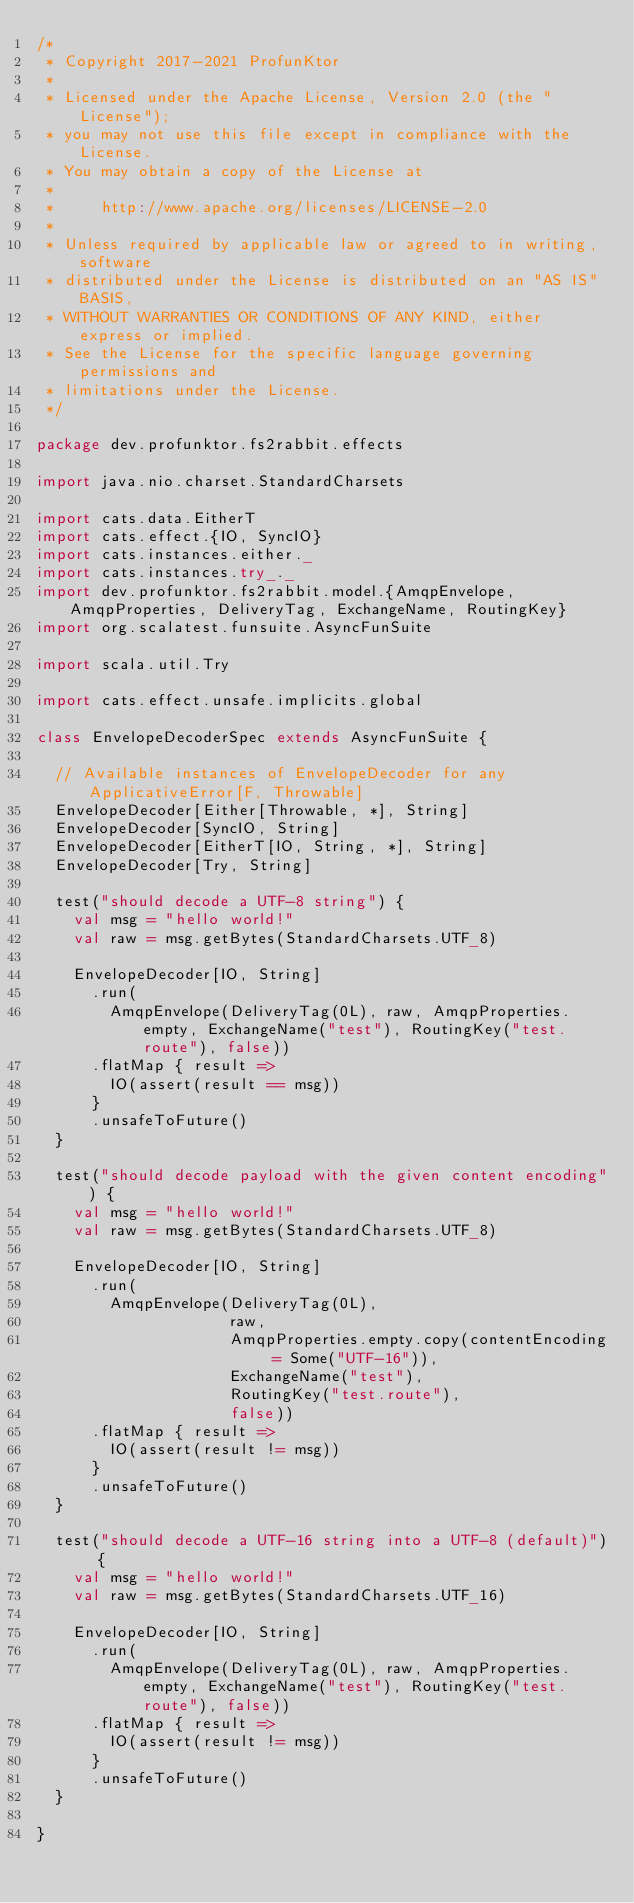<code> <loc_0><loc_0><loc_500><loc_500><_Scala_>/*
 * Copyright 2017-2021 ProfunKtor
 *
 * Licensed under the Apache License, Version 2.0 (the "License");
 * you may not use this file except in compliance with the License.
 * You may obtain a copy of the License at
 *
 *     http://www.apache.org/licenses/LICENSE-2.0
 *
 * Unless required by applicable law or agreed to in writing, software
 * distributed under the License is distributed on an "AS IS" BASIS,
 * WITHOUT WARRANTIES OR CONDITIONS OF ANY KIND, either express or implied.
 * See the License for the specific language governing permissions and
 * limitations under the License.
 */

package dev.profunktor.fs2rabbit.effects

import java.nio.charset.StandardCharsets

import cats.data.EitherT
import cats.effect.{IO, SyncIO}
import cats.instances.either._
import cats.instances.try_._
import dev.profunktor.fs2rabbit.model.{AmqpEnvelope, AmqpProperties, DeliveryTag, ExchangeName, RoutingKey}
import org.scalatest.funsuite.AsyncFunSuite

import scala.util.Try

import cats.effect.unsafe.implicits.global

class EnvelopeDecoderSpec extends AsyncFunSuite {

  // Available instances of EnvelopeDecoder for any ApplicativeError[F, Throwable]
  EnvelopeDecoder[Either[Throwable, *], String]
  EnvelopeDecoder[SyncIO, String]
  EnvelopeDecoder[EitherT[IO, String, *], String]
  EnvelopeDecoder[Try, String]

  test("should decode a UTF-8 string") {
    val msg = "hello world!"
    val raw = msg.getBytes(StandardCharsets.UTF_8)

    EnvelopeDecoder[IO, String]
      .run(
        AmqpEnvelope(DeliveryTag(0L), raw, AmqpProperties.empty, ExchangeName("test"), RoutingKey("test.route"), false))
      .flatMap { result =>
        IO(assert(result == msg))
      }
      .unsafeToFuture()
  }

  test("should decode payload with the given content encoding") {
    val msg = "hello world!"
    val raw = msg.getBytes(StandardCharsets.UTF_8)

    EnvelopeDecoder[IO, String]
      .run(
        AmqpEnvelope(DeliveryTag(0L),
                     raw,
                     AmqpProperties.empty.copy(contentEncoding = Some("UTF-16")),
                     ExchangeName("test"),
                     RoutingKey("test.route"),
                     false))
      .flatMap { result =>
        IO(assert(result != msg))
      }
      .unsafeToFuture()
  }

  test("should decode a UTF-16 string into a UTF-8 (default)") {
    val msg = "hello world!"
    val raw = msg.getBytes(StandardCharsets.UTF_16)

    EnvelopeDecoder[IO, String]
      .run(
        AmqpEnvelope(DeliveryTag(0L), raw, AmqpProperties.empty, ExchangeName("test"), RoutingKey("test.route"), false))
      .flatMap { result =>
        IO(assert(result != msg))
      }
      .unsafeToFuture()
  }

}
</code> 